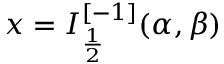Convert formula to latex. <formula><loc_0><loc_0><loc_500><loc_500>x = I _ { \frac { 1 } { 2 } } ^ { [ - 1 ] } ( \alpha , \beta )</formula> 